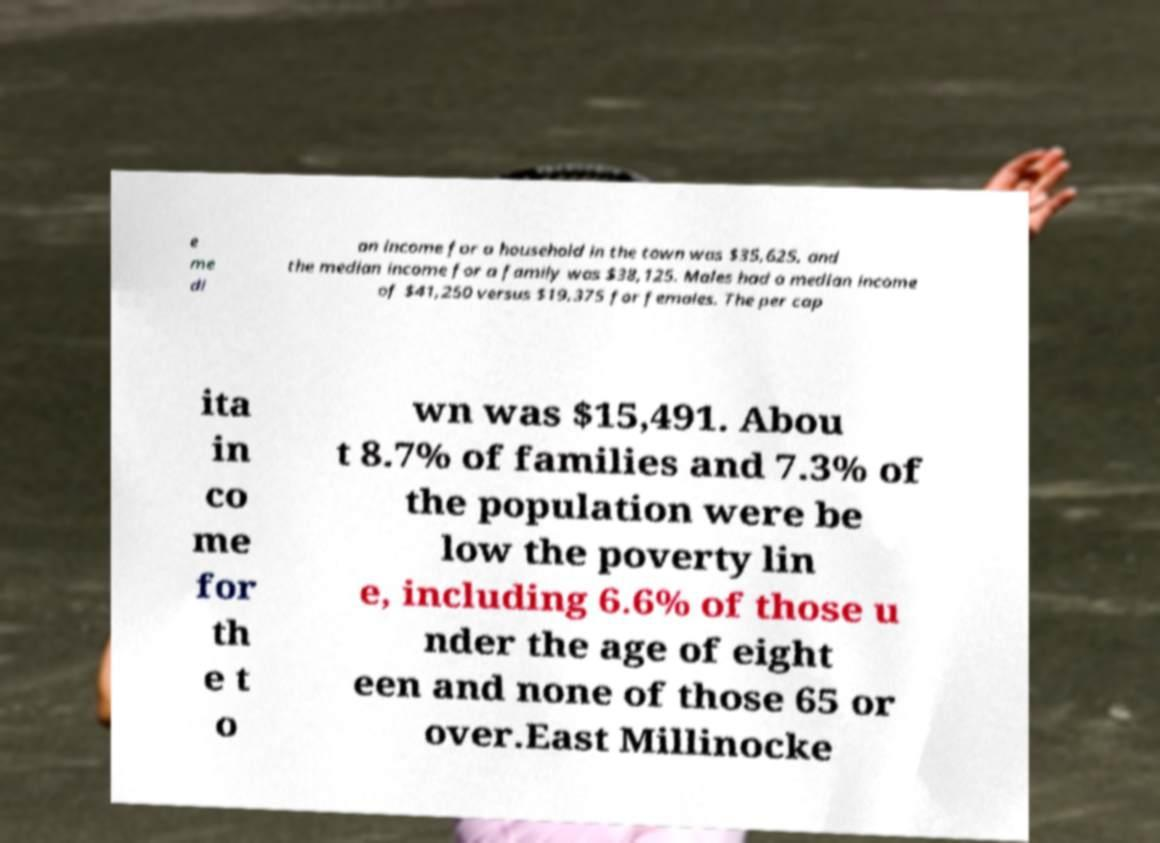Please read and relay the text visible in this image. What does it say? e me di an income for a household in the town was $35,625, and the median income for a family was $38,125. Males had a median income of $41,250 versus $19,375 for females. The per cap ita in co me for th e t o wn was $15,491. Abou t 8.7% of families and 7.3% of the population were be low the poverty lin e, including 6.6% of those u nder the age of eight een and none of those 65 or over.East Millinocke 